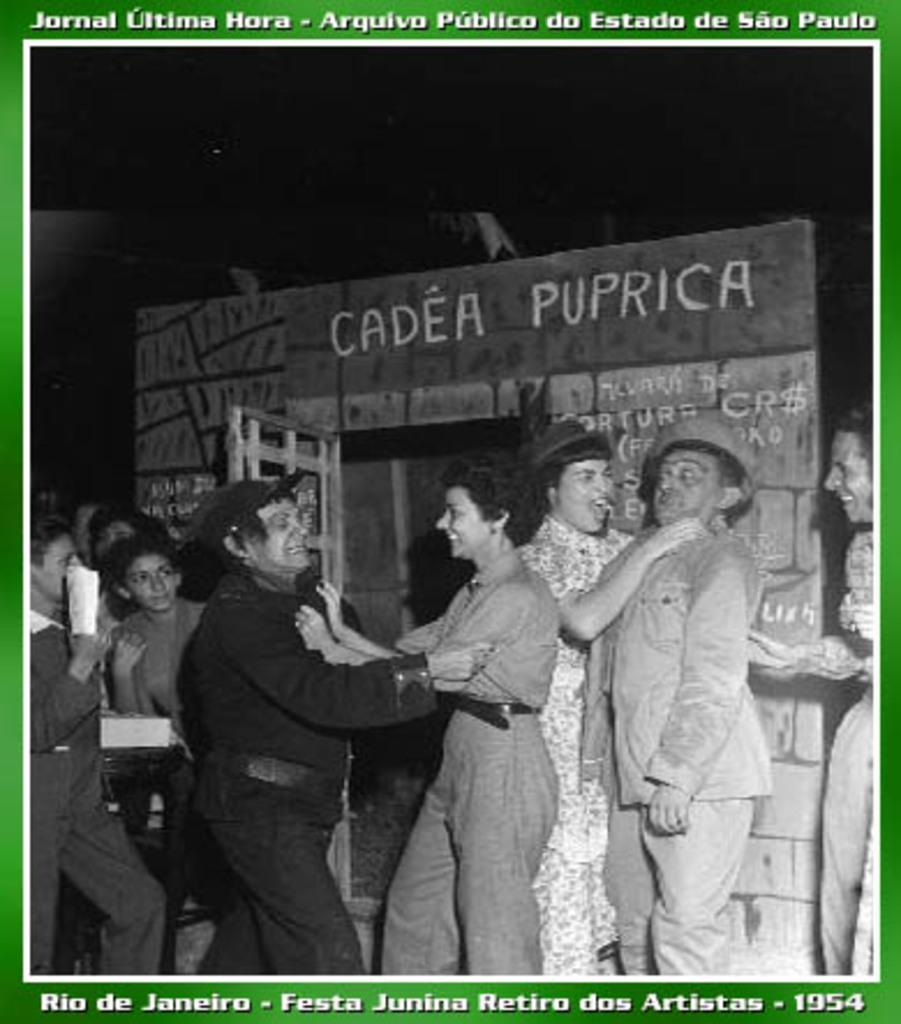How many people are in the image? There are persons in the image, but the exact number cannot be determined from the provided facts. What can be seen in the background of the image? There is an object in the background of the image. What is written above the object? There is something written above the object. What is written below the object? There is something written below the object. What type of grass is growing around the ship in the image? There is no ship or grass present in the image. What type of wine is being served to the persons in the image? There is no mention of wine or any beverage being served in the image. 